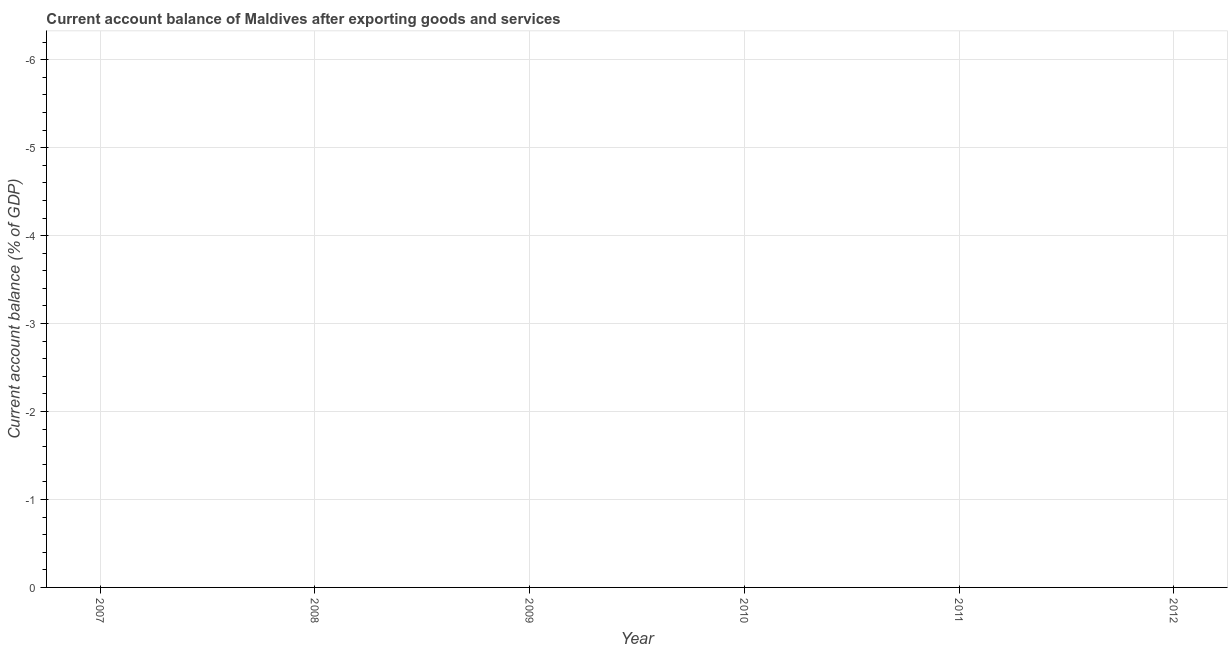What is the current account balance in 2009?
Give a very brief answer. 0. What is the median current account balance?
Ensure brevity in your answer.  0. In how many years, is the current account balance greater than -2.8 %?
Keep it short and to the point. 0. In how many years, is the current account balance greater than the average current account balance taken over all years?
Provide a short and direct response. 0. What is the difference between two consecutive major ticks on the Y-axis?
Ensure brevity in your answer.  1. Are the values on the major ticks of Y-axis written in scientific E-notation?
Keep it short and to the point. No. Does the graph contain any zero values?
Provide a short and direct response. Yes. What is the title of the graph?
Your answer should be very brief. Current account balance of Maldives after exporting goods and services. What is the label or title of the X-axis?
Make the answer very short. Year. What is the label or title of the Y-axis?
Make the answer very short. Current account balance (% of GDP). What is the Current account balance (% of GDP) in 2007?
Give a very brief answer. 0. What is the Current account balance (% of GDP) in 2010?
Ensure brevity in your answer.  0. What is the Current account balance (% of GDP) in 2011?
Your answer should be very brief. 0. What is the Current account balance (% of GDP) in 2012?
Ensure brevity in your answer.  0. 